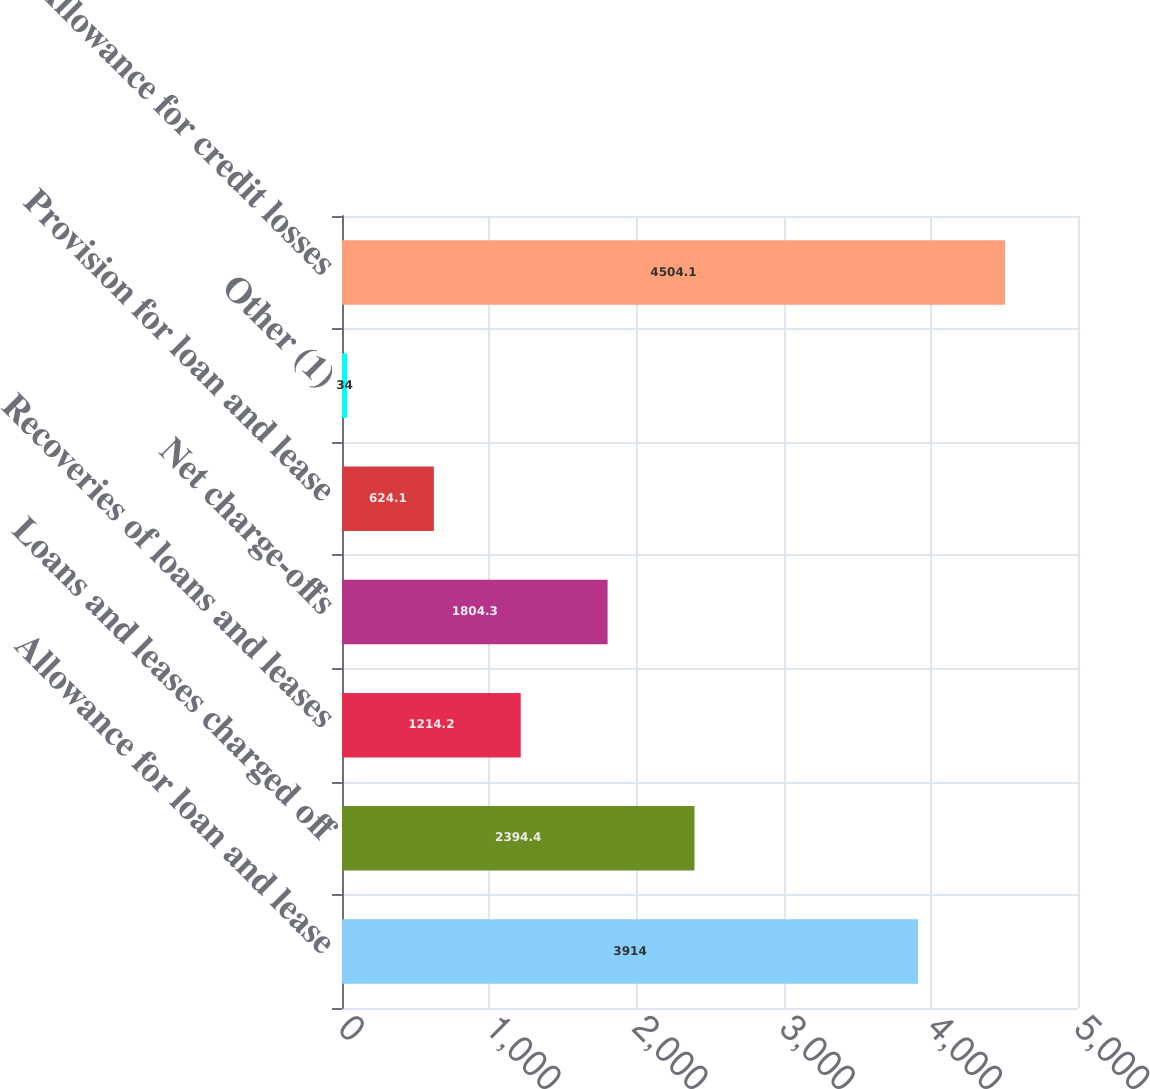<chart> <loc_0><loc_0><loc_500><loc_500><bar_chart><fcel>Allowance for loan and lease<fcel>Loans and leases charged off<fcel>Recoveries of loans and leases<fcel>Net charge-offs<fcel>Provision for loan and lease<fcel>Other (1)<fcel>Allowance for credit losses<nl><fcel>3914<fcel>2394.4<fcel>1214.2<fcel>1804.3<fcel>624.1<fcel>34<fcel>4504.1<nl></chart> 